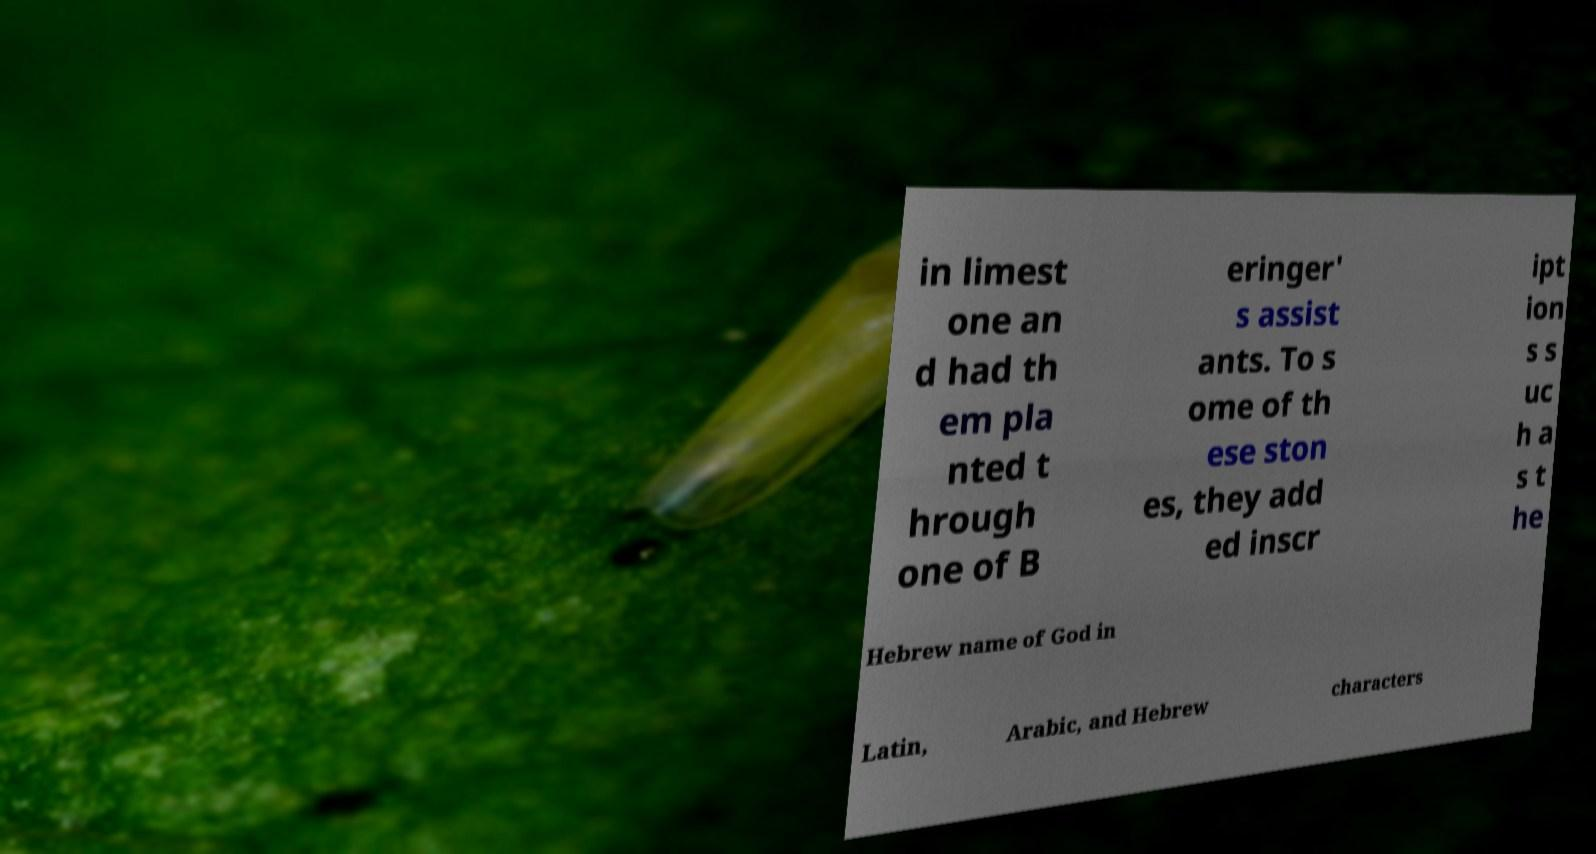What messages or text are displayed in this image? I need them in a readable, typed format. in limest one an d had th em pla nted t hrough one of B eringer' s assist ants. To s ome of th ese ston es, they add ed inscr ipt ion s s uc h a s t he Hebrew name of God in Latin, Arabic, and Hebrew characters 